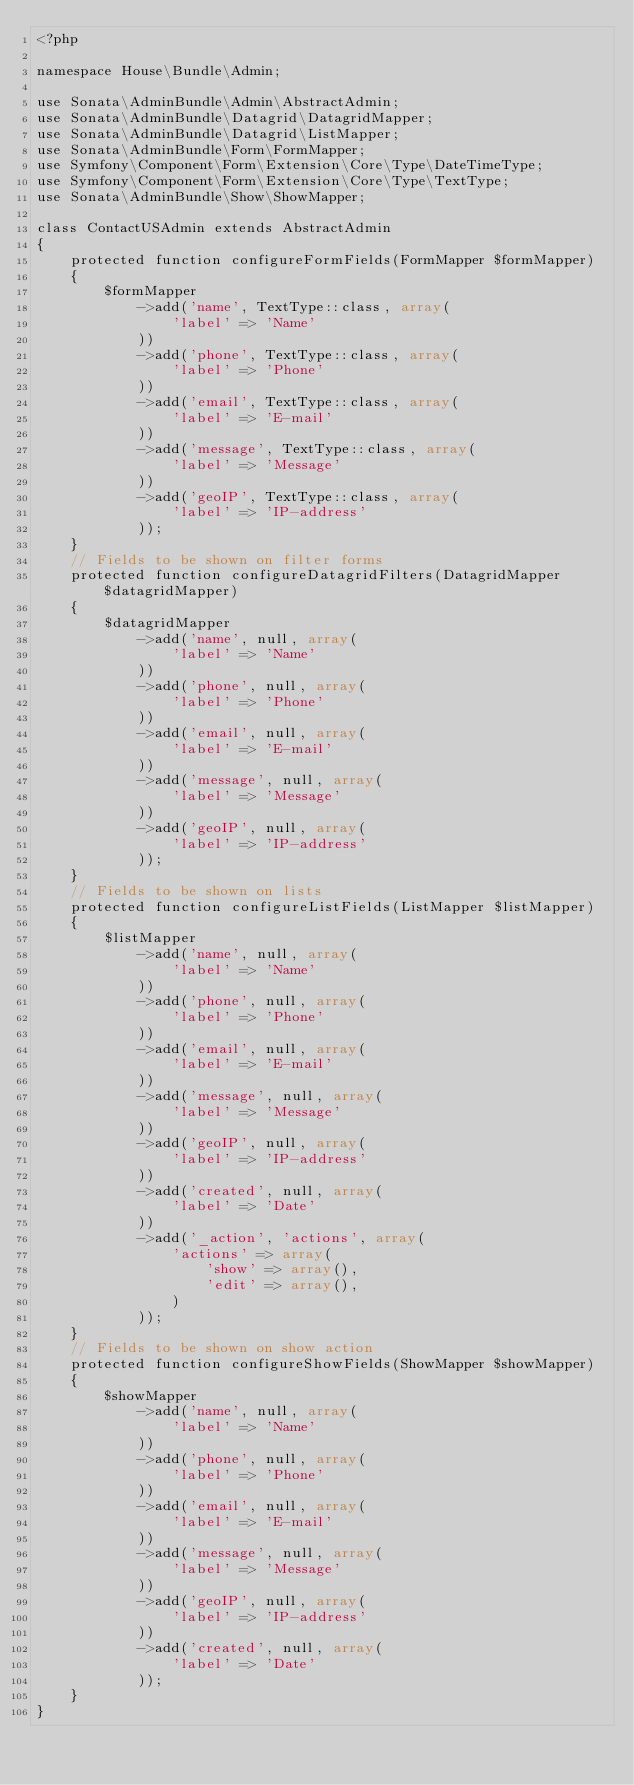<code> <loc_0><loc_0><loc_500><loc_500><_PHP_><?php

namespace House\Bundle\Admin;

use Sonata\AdminBundle\Admin\AbstractAdmin;
use Sonata\AdminBundle\Datagrid\DatagridMapper;
use Sonata\AdminBundle\Datagrid\ListMapper;
use Sonata\AdminBundle\Form\FormMapper;
use Symfony\Component\Form\Extension\Core\Type\DateTimeType;
use Symfony\Component\Form\Extension\Core\Type\TextType;
use Sonata\AdminBundle\Show\ShowMapper;

class ContactUSAdmin extends AbstractAdmin
{
    protected function configureFormFields(FormMapper $formMapper)
    {
        $formMapper
            ->add('name', TextType::class, array(
                'label' => 'Name'
            ))
            ->add('phone', TextType::class, array(
                'label' => 'Phone'
            ))
            ->add('email', TextType::class, array(
                'label' => 'E-mail'
            ))
            ->add('message', TextType::class, array(
                'label' => 'Message'
            ))
            ->add('geoIP', TextType::class, array(
                'label' => 'IP-address'
            ));
    }
    // Fields to be shown on filter forms
    protected function configureDatagridFilters(DatagridMapper $datagridMapper)
    {
        $datagridMapper
            ->add('name', null, array(
                'label' => 'Name'
            ))
            ->add('phone', null, array(
                'label' => 'Phone'
            ))
            ->add('email', null, array(
                'label' => 'E-mail'
            ))
            ->add('message', null, array(
                'label' => 'Message'
            ))
            ->add('geoIP', null, array(
                'label' => 'IP-address'
            ));
    }
    // Fields to be shown on lists
    protected function configureListFields(ListMapper $listMapper)
    {
        $listMapper
            ->add('name', null, array(
                'label' => 'Name'
            ))
            ->add('phone', null, array(
                'label' => 'Phone'
            ))
            ->add('email', null, array(
                'label' => 'E-mail'
            ))
            ->add('message', null, array(
                'label' => 'Message'
            ))
            ->add('geoIP', null, array(
                'label' => 'IP-address'
            ))
            ->add('created', null, array(
                'label' => 'Date'
            ))
            ->add('_action', 'actions', array(
                'actions' => array(
                    'show' => array(),
                    'edit' => array(),
                )
            ));
    }
    // Fields to be shown on show action
    protected function configureShowFields(ShowMapper $showMapper)
    {
        $showMapper
            ->add('name', null, array(
                'label' => 'Name'
            ))
            ->add('phone', null, array(
                'label' => 'Phone'
            ))
            ->add('email', null, array(
                'label' => 'E-mail'
            ))
            ->add('message', null, array(
                'label' => 'Message'
            ))
            ->add('geoIP', null, array(
                'label' => 'IP-address'
            ))
            ->add('created', null, array(
                'label' => 'Date'
            ));
    }
}</code> 